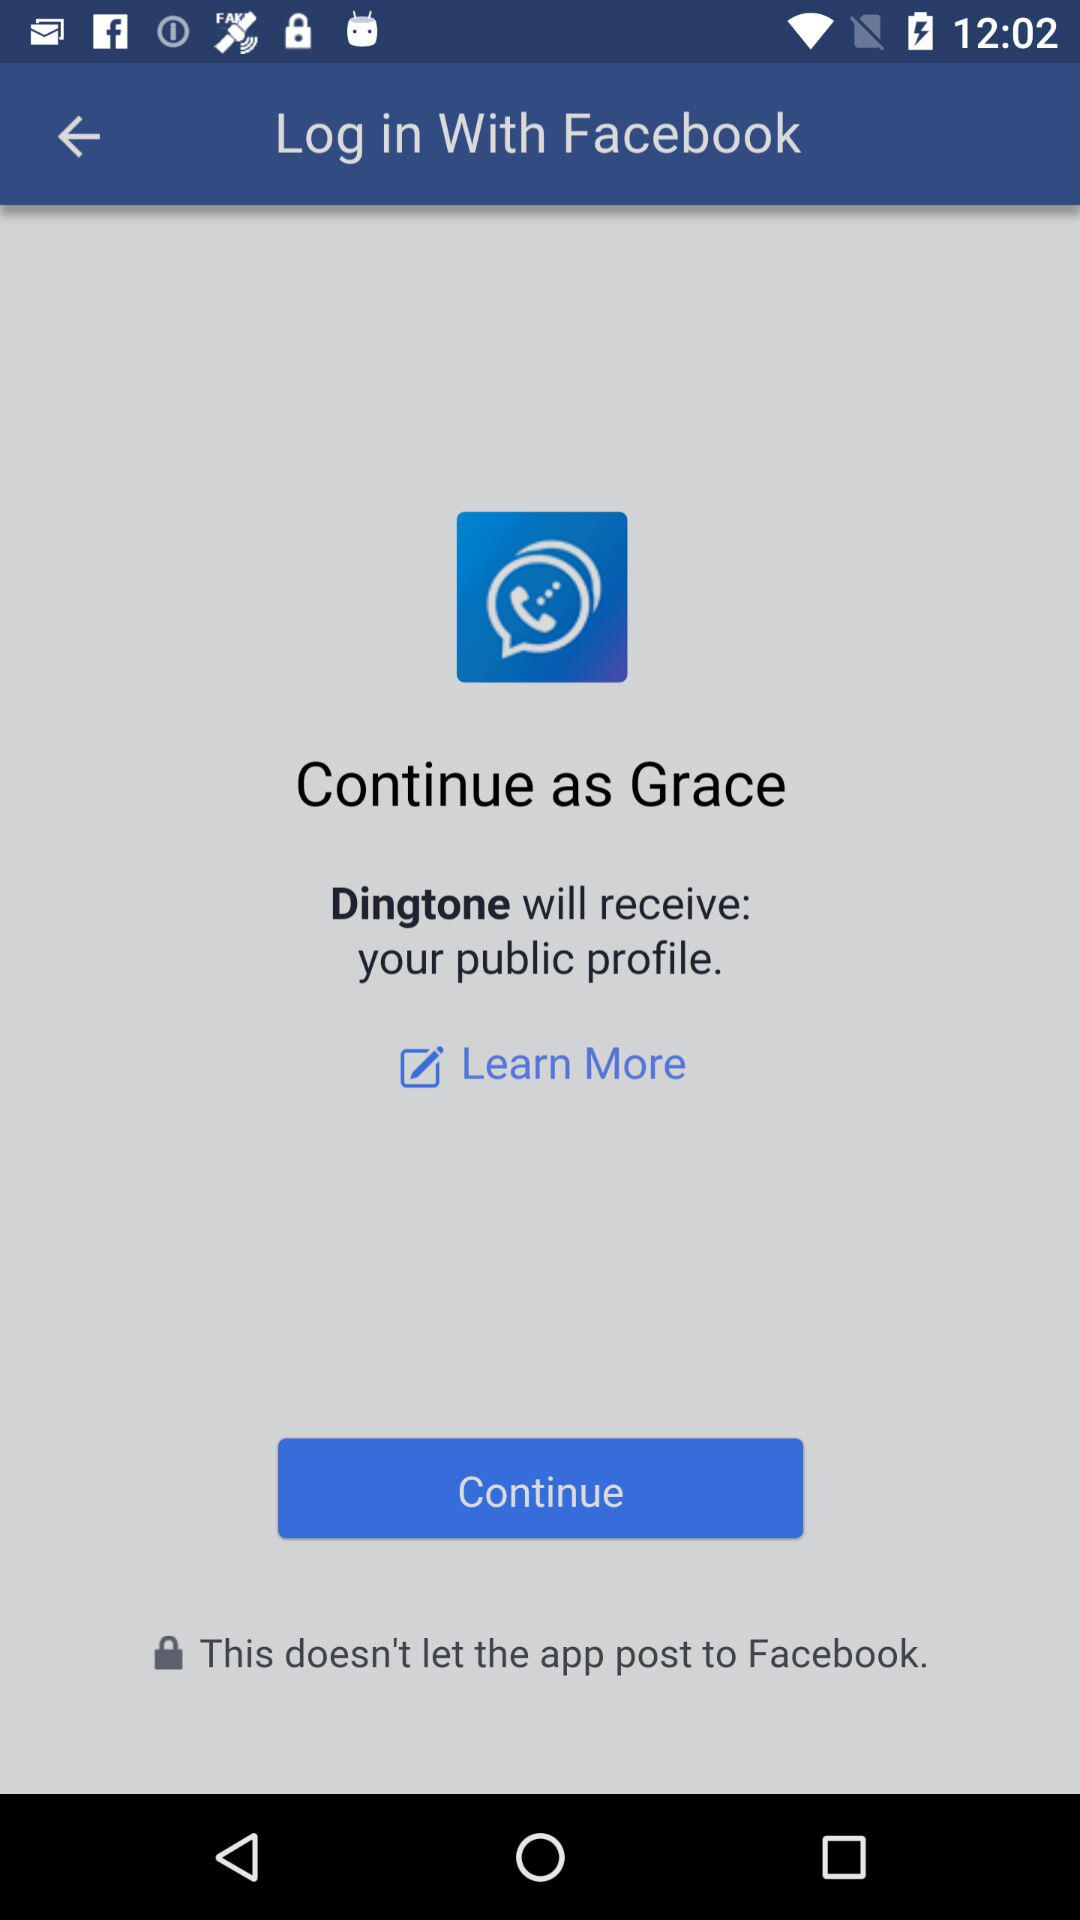What is the login name? The login name is Grace. 